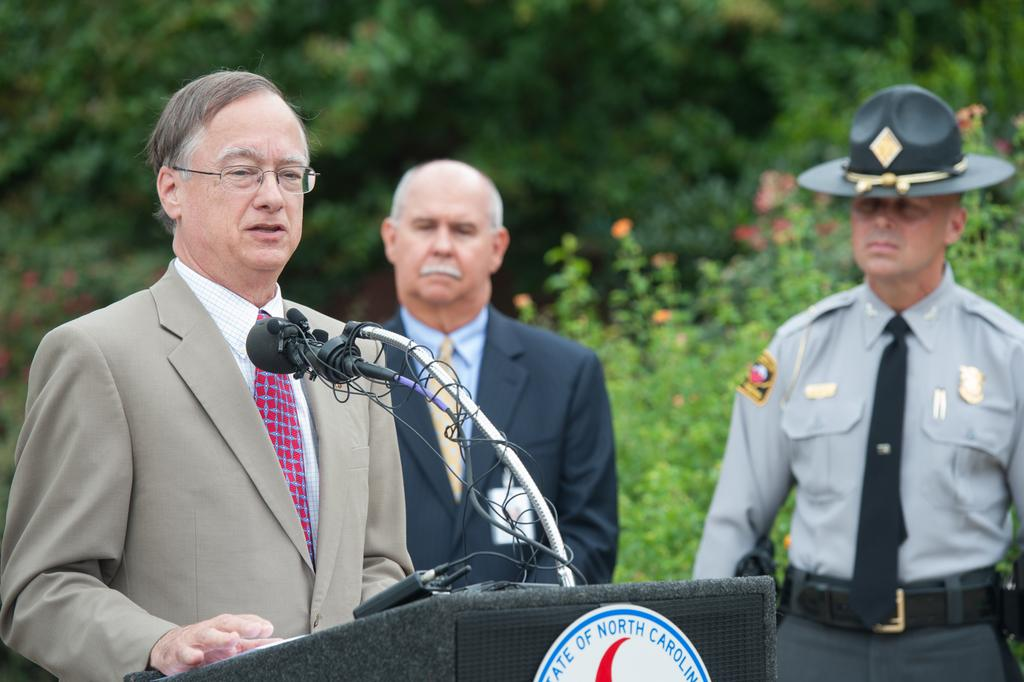What is the man in the image doing near the podium? The man is standing near a podium in the image. What objects are present for amplifying sound in the image? There are microphones (mikes) in the image. How many people are present in the image? There are two people standing in the image. What can be seen in the background of the image? There are trees and plants with flowers in the background of the image. What type of soup is being served in the image? There is no soup present in the image. What color is the vest worn by the man in the image? The provided facts do not mention the color of any clothing worn by the man in the image. 